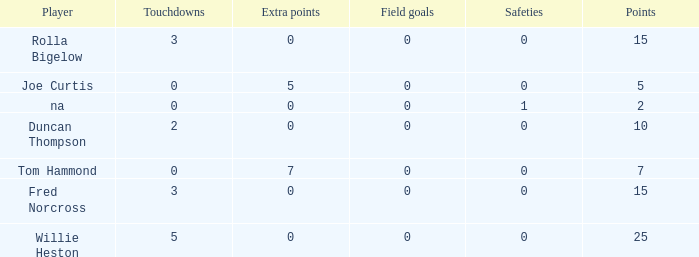How many Touchdowns have a Player of rolla bigelow, and an Extra points smaller than 0? None. 